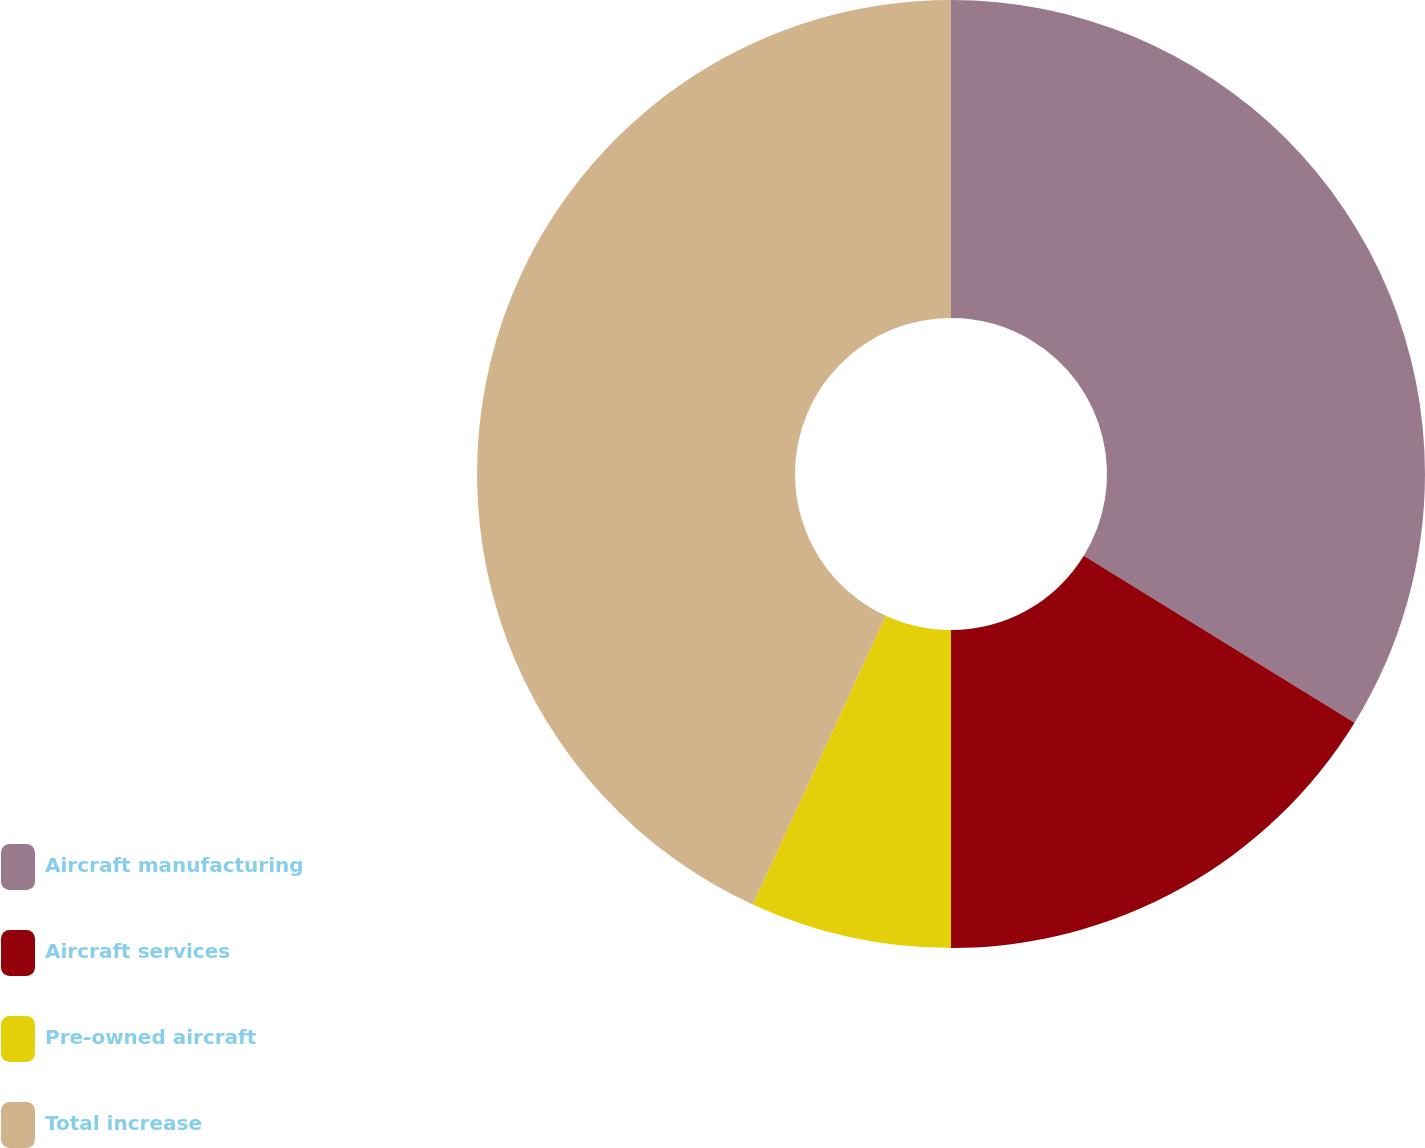<chart> <loc_0><loc_0><loc_500><loc_500><pie_chart><fcel>Aircraft manufacturing<fcel>Aircraft services<fcel>Pre-owned aircraft<fcel>Total increase<nl><fcel>33.79%<fcel>16.21%<fcel>6.87%<fcel>43.13%<nl></chart> 